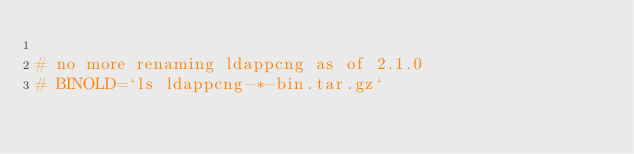Convert code to text. <code><loc_0><loc_0><loc_500><loc_500><_Bash_> 
# no more renaming ldappcng as of 2.1.0
# BINOLD=`ls ldappcng-*-bin.tar.gz`</code> 